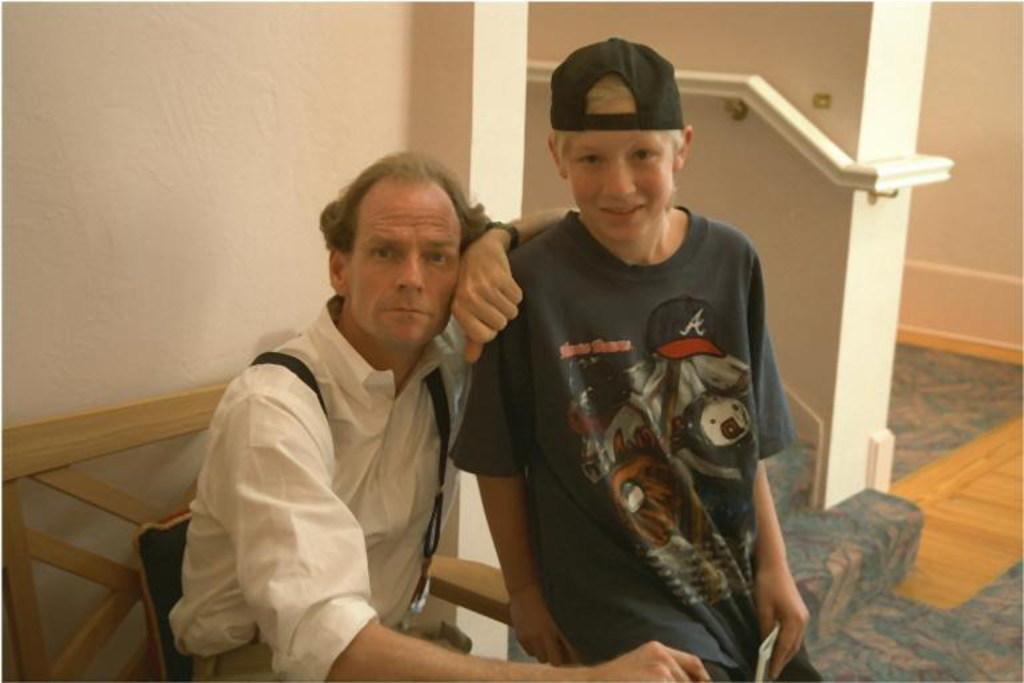Describe this image in one or two sentences. This image consists of two persons. One is sitting in a chair. There are stairs in the middle. One of them is wearing a cap. 